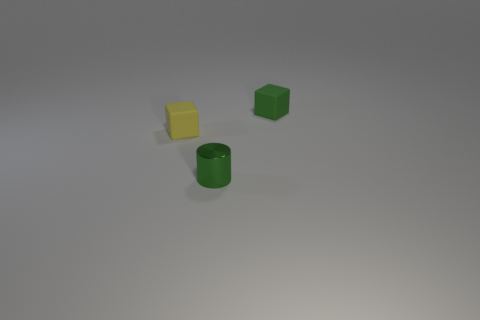Add 2 cylinders. How many objects exist? 5 Subtract all green cubes. How many cubes are left? 1 Subtract all blocks. How many objects are left? 1 Subtract 2 cubes. How many cubes are left? 0 Subtract 0 purple cubes. How many objects are left? 3 Subtract all yellow cubes. Subtract all blue spheres. How many cubes are left? 1 Subtract all green blocks. How many gray cylinders are left? 0 Subtract all green blocks. Subtract all large blue matte objects. How many objects are left? 2 Add 2 green matte objects. How many green matte objects are left? 3 Add 2 green blocks. How many green blocks exist? 3 